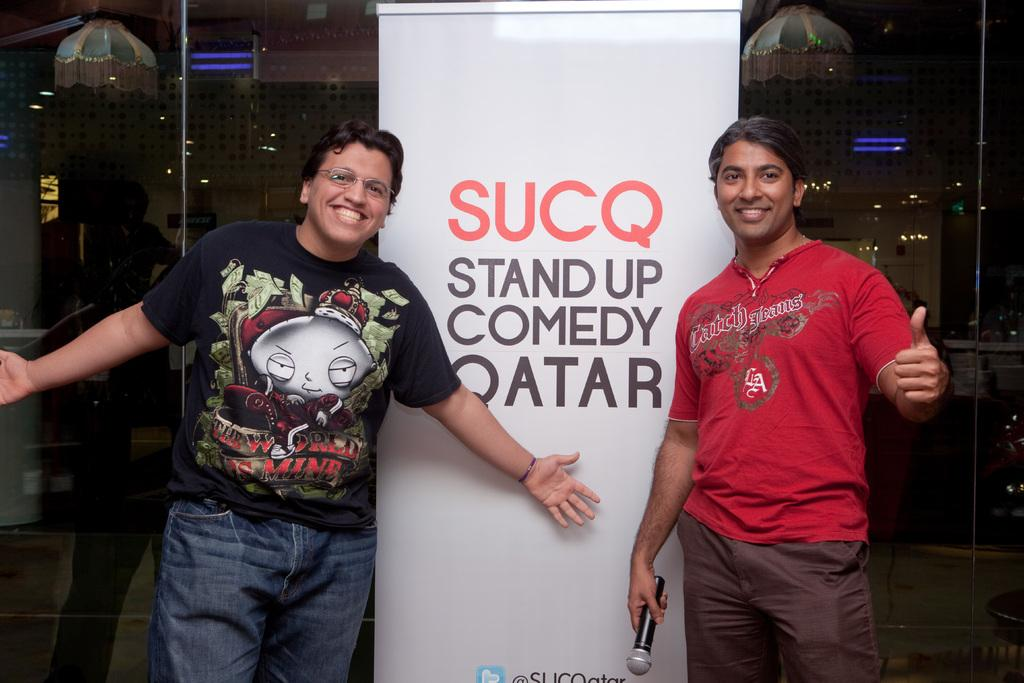How many people are in the image? There are two people standing in the image. What are the expressions on their faces? Both people are smiling. What is the man on the right holding? The man on the right is holding a mic. What can be seen in the center of the image? There is a banner in the center of the image. What is visible in the background of the image? There is a glass visible in the background of the image. What type of clock is hanging on the wall behind the people? There is no clock visible in the image; only a banner and a glass are present in the background. 